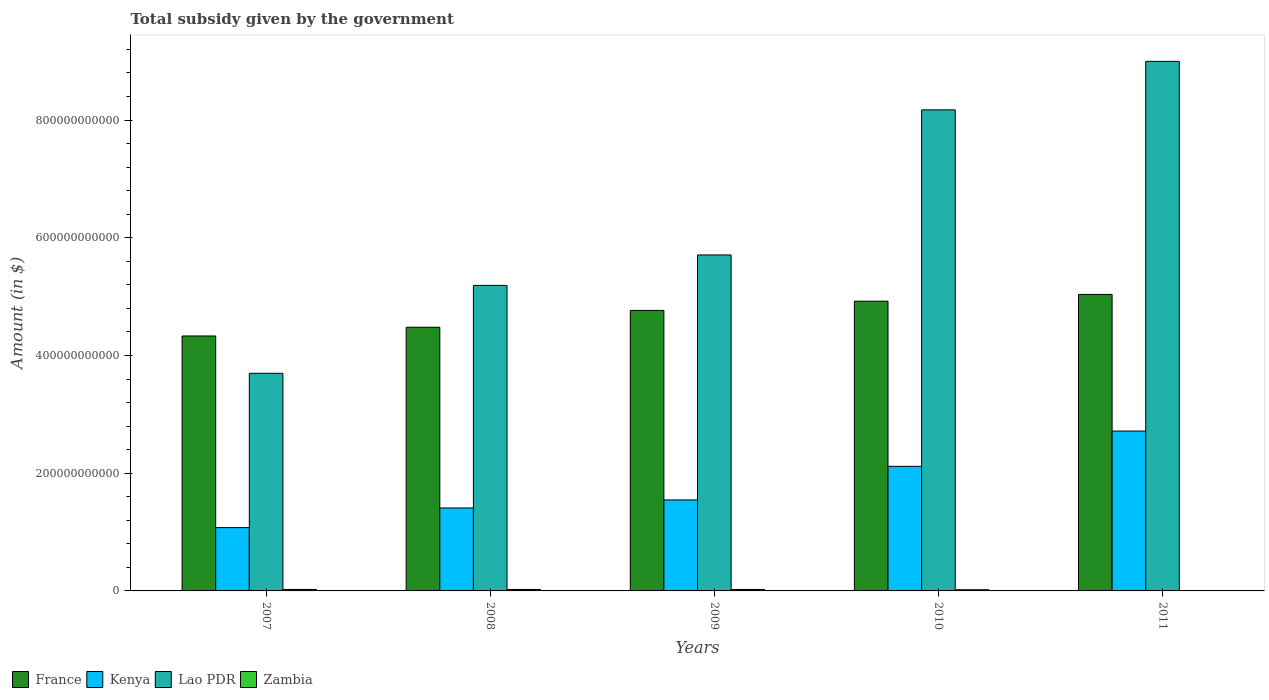How many groups of bars are there?
Your answer should be compact. 5. Are the number of bars on each tick of the X-axis equal?
Provide a short and direct response. Yes. How many bars are there on the 5th tick from the right?
Your response must be concise. 4. What is the label of the 3rd group of bars from the left?
Make the answer very short. 2009. What is the total revenue collected by the government in Zambia in 2007?
Ensure brevity in your answer.  2.52e+09. Across all years, what is the maximum total revenue collected by the government in Kenya?
Give a very brief answer. 2.72e+11. Across all years, what is the minimum total revenue collected by the government in France?
Offer a very short reply. 4.33e+11. In which year was the total revenue collected by the government in Kenya minimum?
Your response must be concise. 2007. What is the total total revenue collected by the government in Zambia in the graph?
Give a very brief answer. 1.02e+1. What is the difference between the total revenue collected by the government in Kenya in 2007 and that in 2010?
Make the answer very short. -1.04e+11. What is the difference between the total revenue collected by the government in France in 2011 and the total revenue collected by the government in Lao PDR in 2007?
Your answer should be very brief. 1.34e+11. What is the average total revenue collected by the government in Lao PDR per year?
Your answer should be very brief. 6.35e+11. In the year 2009, what is the difference between the total revenue collected by the government in France and total revenue collected by the government in Lao PDR?
Make the answer very short. -9.43e+1. What is the ratio of the total revenue collected by the government in Zambia in 2008 to that in 2010?
Keep it short and to the point. 1.22. What is the difference between the highest and the second highest total revenue collected by the government in France?
Offer a very short reply. 1.14e+1. What is the difference between the highest and the lowest total revenue collected by the government in France?
Offer a very short reply. 7.06e+1. What does the 2nd bar from the left in 2009 represents?
Your response must be concise. Kenya. What does the 1st bar from the right in 2010 represents?
Offer a very short reply. Zambia. Is it the case that in every year, the sum of the total revenue collected by the government in France and total revenue collected by the government in Zambia is greater than the total revenue collected by the government in Kenya?
Keep it short and to the point. Yes. How many years are there in the graph?
Your answer should be very brief. 5. What is the difference between two consecutive major ticks on the Y-axis?
Offer a terse response. 2.00e+11. Are the values on the major ticks of Y-axis written in scientific E-notation?
Your answer should be very brief. No. Does the graph contain any zero values?
Provide a short and direct response. No. Where does the legend appear in the graph?
Your response must be concise. Bottom left. How are the legend labels stacked?
Ensure brevity in your answer.  Horizontal. What is the title of the graph?
Ensure brevity in your answer.  Total subsidy given by the government. Does "Sub-Saharan Africa (developing only)" appear as one of the legend labels in the graph?
Your answer should be very brief. No. What is the label or title of the Y-axis?
Your response must be concise. Amount (in $). What is the Amount (in $) in France in 2007?
Keep it short and to the point. 4.33e+11. What is the Amount (in $) in Kenya in 2007?
Keep it short and to the point. 1.08e+11. What is the Amount (in $) of Lao PDR in 2007?
Provide a short and direct response. 3.70e+11. What is the Amount (in $) of Zambia in 2007?
Give a very brief answer. 2.52e+09. What is the Amount (in $) of France in 2008?
Offer a terse response. 4.48e+11. What is the Amount (in $) in Kenya in 2008?
Keep it short and to the point. 1.41e+11. What is the Amount (in $) in Lao PDR in 2008?
Keep it short and to the point. 5.19e+11. What is the Amount (in $) of Zambia in 2008?
Ensure brevity in your answer.  2.48e+09. What is the Amount (in $) in France in 2009?
Offer a very short reply. 4.77e+11. What is the Amount (in $) in Kenya in 2009?
Offer a terse response. 1.55e+11. What is the Amount (in $) in Lao PDR in 2009?
Your answer should be compact. 5.71e+11. What is the Amount (in $) in Zambia in 2009?
Offer a very short reply. 2.49e+09. What is the Amount (in $) in France in 2010?
Make the answer very short. 4.92e+11. What is the Amount (in $) of Kenya in 2010?
Your answer should be compact. 2.12e+11. What is the Amount (in $) in Lao PDR in 2010?
Provide a short and direct response. 8.17e+11. What is the Amount (in $) of Zambia in 2010?
Your answer should be very brief. 2.04e+09. What is the Amount (in $) in France in 2011?
Your response must be concise. 5.04e+11. What is the Amount (in $) in Kenya in 2011?
Provide a succinct answer. 2.72e+11. What is the Amount (in $) of Lao PDR in 2011?
Your answer should be very brief. 9.00e+11. What is the Amount (in $) of Zambia in 2011?
Your answer should be very brief. 6.94e+08. Across all years, what is the maximum Amount (in $) of France?
Provide a short and direct response. 5.04e+11. Across all years, what is the maximum Amount (in $) in Kenya?
Give a very brief answer. 2.72e+11. Across all years, what is the maximum Amount (in $) of Lao PDR?
Your answer should be compact. 9.00e+11. Across all years, what is the maximum Amount (in $) of Zambia?
Offer a very short reply. 2.52e+09. Across all years, what is the minimum Amount (in $) in France?
Give a very brief answer. 4.33e+11. Across all years, what is the minimum Amount (in $) of Kenya?
Make the answer very short. 1.08e+11. Across all years, what is the minimum Amount (in $) in Lao PDR?
Offer a very short reply. 3.70e+11. Across all years, what is the minimum Amount (in $) in Zambia?
Offer a very short reply. 6.94e+08. What is the total Amount (in $) in France in the graph?
Offer a very short reply. 2.35e+12. What is the total Amount (in $) of Kenya in the graph?
Give a very brief answer. 8.86e+11. What is the total Amount (in $) of Lao PDR in the graph?
Your answer should be compact. 3.18e+12. What is the total Amount (in $) of Zambia in the graph?
Ensure brevity in your answer.  1.02e+1. What is the difference between the Amount (in $) in France in 2007 and that in 2008?
Make the answer very short. -1.49e+1. What is the difference between the Amount (in $) in Kenya in 2007 and that in 2008?
Keep it short and to the point. -3.34e+1. What is the difference between the Amount (in $) of Lao PDR in 2007 and that in 2008?
Your response must be concise. -1.49e+11. What is the difference between the Amount (in $) in Zambia in 2007 and that in 2008?
Your answer should be very brief. 4.39e+07. What is the difference between the Amount (in $) in France in 2007 and that in 2009?
Provide a short and direct response. -4.34e+1. What is the difference between the Amount (in $) in Kenya in 2007 and that in 2009?
Ensure brevity in your answer.  -4.70e+1. What is the difference between the Amount (in $) of Lao PDR in 2007 and that in 2009?
Offer a terse response. -2.01e+11. What is the difference between the Amount (in $) of Zambia in 2007 and that in 2009?
Provide a short and direct response. 2.92e+07. What is the difference between the Amount (in $) of France in 2007 and that in 2010?
Your answer should be very brief. -5.92e+1. What is the difference between the Amount (in $) of Kenya in 2007 and that in 2010?
Provide a short and direct response. -1.04e+11. What is the difference between the Amount (in $) of Lao PDR in 2007 and that in 2010?
Offer a terse response. -4.48e+11. What is the difference between the Amount (in $) of Zambia in 2007 and that in 2010?
Your answer should be very brief. 4.87e+08. What is the difference between the Amount (in $) in France in 2007 and that in 2011?
Your answer should be very brief. -7.06e+1. What is the difference between the Amount (in $) in Kenya in 2007 and that in 2011?
Your answer should be compact. -1.64e+11. What is the difference between the Amount (in $) of Lao PDR in 2007 and that in 2011?
Offer a terse response. -5.30e+11. What is the difference between the Amount (in $) in Zambia in 2007 and that in 2011?
Make the answer very short. 1.83e+09. What is the difference between the Amount (in $) of France in 2008 and that in 2009?
Offer a very short reply. -2.86e+1. What is the difference between the Amount (in $) of Kenya in 2008 and that in 2009?
Give a very brief answer. -1.37e+1. What is the difference between the Amount (in $) in Lao PDR in 2008 and that in 2009?
Make the answer very short. -5.17e+1. What is the difference between the Amount (in $) in Zambia in 2008 and that in 2009?
Offer a very short reply. -1.47e+07. What is the difference between the Amount (in $) in France in 2008 and that in 2010?
Make the answer very short. -4.43e+1. What is the difference between the Amount (in $) of Kenya in 2008 and that in 2010?
Provide a succinct answer. -7.07e+1. What is the difference between the Amount (in $) in Lao PDR in 2008 and that in 2010?
Provide a short and direct response. -2.98e+11. What is the difference between the Amount (in $) of Zambia in 2008 and that in 2010?
Your response must be concise. 4.43e+08. What is the difference between the Amount (in $) in France in 2008 and that in 2011?
Your answer should be compact. -5.57e+1. What is the difference between the Amount (in $) in Kenya in 2008 and that in 2011?
Your answer should be compact. -1.31e+11. What is the difference between the Amount (in $) of Lao PDR in 2008 and that in 2011?
Offer a terse response. -3.81e+11. What is the difference between the Amount (in $) in Zambia in 2008 and that in 2011?
Offer a very short reply. 1.78e+09. What is the difference between the Amount (in $) of France in 2009 and that in 2010?
Your response must be concise. -1.57e+1. What is the difference between the Amount (in $) of Kenya in 2009 and that in 2010?
Give a very brief answer. -5.71e+1. What is the difference between the Amount (in $) of Lao PDR in 2009 and that in 2010?
Keep it short and to the point. -2.47e+11. What is the difference between the Amount (in $) in Zambia in 2009 and that in 2010?
Offer a terse response. 4.58e+08. What is the difference between the Amount (in $) of France in 2009 and that in 2011?
Your answer should be compact. -2.72e+1. What is the difference between the Amount (in $) in Kenya in 2009 and that in 2011?
Ensure brevity in your answer.  -1.17e+11. What is the difference between the Amount (in $) in Lao PDR in 2009 and that in 2011?
Make the answer very short. -3.29e+11. What is the difference between the Amount (in $) in Zambia in 2009 and that in 2011?
Offer a terse response. 1.80e+09. What is the difference between the Amount (in $) of France in 2010 and that in 2011?
Your response must be concise. -1.14e+1. What is the difference between the Amount (in $) in Kenya in 2010 and that in 2011?
Make the answer very short. -6.00e+1. What is the difference between the Amount (in $) of Lao PDR in 2010 and that in 2011?
Give a very brief answer. -8.24e+1. What is the difference between the Amount (in $) in Zambia in 2010 and that in 2011?
Provide a short and direct response. 1.34e+09. What is the difference between the Amount (in $) in France in 2007 and the Amount (in $) in Kenya in 2008?
Your answer should be compact. 2.92e+11. What is the difference between the Amount (in $) in France in 2007 and the Amount (in $) in Lao PDR in 2008?
Provide a short and direct response. -8.59e+1. What is the difference between the Amount (in $) of France in 2007 and the Amount (in $) of Zambia in 2008?
Provide a succinct answer. 4.31e+11. What is the difference between the Amount (in $) in Kenya in 2007 and the Amount (in $) in Lao PDR in 2008?
Provide a short and direct response. -4.12e+11. What is the difference between the Amount (in $) of Kenya in 2007 and the Amount (in $) of Zambia in 2008?
Provide a short and direct response. 1.05e+11. What is the difference between the Amount (in $) of Lao PDR in 2007 and the Amount (in $) of Zambia in 2008?
Your answer should be compact. 3.67e+11. What is the difference between the Amount (in $) in France in 2007 and the Amount (in $) in Kenya in 2009?
Keep it short and to the point. 2.79e+11. What is the difference between the Amount (in $) of France in 2007 and the Amount (in $) of Lao PDR in 2009?
Offer a very short reply. -1.38e+11. What is the difference between the Amount (in $) in France in 2007 and the Amount (in $) in Zambia in 2009?
Your answer should be compact. 4.31e+11. What is the difference between the Amount (in $) of Kenya in 2007 and the Amount (in $) of Lao PDR in 2009?
Give a very brief answer. -4.63e+11. What is the difference between the Amount (in $) of Kenya in 2007 and the Amount (in $) of Zambia in 2009?
Provide a short and direct response. 1.05e+11. What is the difference between the Amount (in $) of Lao PDR in 2007 and the Amount (in $) of Zambia in 2009?
Ensure brevity in your answer.  3.67e+11. What is the difference between the Amount (in $) in France in 2007 and the Amount (in $) in Kenya in 2010?
Give a very brief answer. 2.21e+11. What is the difference between the Amount (in $) in France in 2007 and the Amount (in $) in Lao PDR in 2010?
Make the answer very short. -3.84e+11. What is the difference between the Amount (in $) in France in 2007 and the Amount (in $) in Zambia in 2010?
Provide a succinct answer. 4.31e+11. What is the difference between the Amount (in $) of Kenya in 2007 and the Amount (in $) of Lao PDR in 2010?
Offer a very short reply. -7.10e+11. What is the difference between the Amount (in $) of Kenya in 2007 and the Amount (in $) of Zambia in 2010?
Offer a terse response. 1.06e+11. What is the difference between the Amount (in $) in Lao PDR in 2007 and the Amount (in $) in Zambia in 2010?
Offer a terse response. 3.68e+11. What is the difference between the Amount (in $) in France in 2007 and the Amount (in $) in Kenya in 2011?
Your response must be concise. 1.62e+11. What is the difference between the Amount (in $) in France in 2007 and the Amount (in $) in Lao PDR in 2011?
Provide a succinct answer. -4.67e+11. What is the difference between the Amount (in $) of France in 2007 and the Amount (in $) of Zambia in 2011?
Offer a very short reply. 4.32e+11. What is the difference between the Amount (in $) of Kenya in 2007 and the Amount (in $) of Lao PDR in 2011?
Your response must be concise. -7.92e+11. What is the difference between the Amount (in $) of Kenya in 2007 and the Amount (in $) of Zambia in 2011?
Provide a succinct answer. 1.07e+11. What is the difference between the Amount (in $) in Lao PDR in 2007 and the Amount (in $) in Zambia in 2011?
Make the answer very short. 3.69e+11. What is the difference between the Amount (in $) in France in 2008 and the Amount (in $) in Kenya in 2009?
Provide a short and direct response. 2.93e+11. What is the difference between the Amount (in $) in France in 2008 and the Amount (in $) in Lao PDR in 2009?
Give a very brief answer. -1.23e+11. What is the difference between the Amount (in $) in France in 2008 and the Amount (in $) in Zambia in 2009?
Give a very brief answer. 4.46e+11. What is the difference between the Amount (in $) of Kenya in 2008 and the Amount (in $) of Lao PDR in 2009?
Provide a short and direct response. -4.30e+11. What is the difference between the Amount (in $) in Kenya in 2008 and the Amount (in $) in Zambia in 2009?
Offer a very short reply. 1.38e+11. What is the difference between the Amount (in $) of Lao PDR in 2008 and the Amount (in $) of Zambia in 2009?
Your response must be concise. 5.17e+11. What is the difference between the Amount (in $) in France in 2008 and the Amount (in $) in Kenya in 2010?
Offer a terse response. 2.36e+11. What is the difference between the Amount (in $) of France in 2008 and the Amount (in $) of Lao PDR in 2010?
Offer a terse response. -3.69e+11. What is the difference between the Amount (in $) of France in 2008 and the Amount (in $) of Zambia in 2010?
Your response must be concise. 4.46e+11. What is the difference between the Amount (in $) in Kenya in 2008 and the Amount (in $) in Lao PDR in 2010?
Ensure brevity in your answer.  -6.76e+11. What is the difference between the Amount (in $) of Kenya in 2008 and the Amount (in $) of Zambia in 2010?
Your response must be concise. 1.39e+11. What is the difference between the Amount (in $) of Lao PDR in 2008 and the Amount (in $) of Zambia in 2010?
Your answer should be compact. 5.17e+11. What is the difference between the Amount (in $) of France in 2008 and the Amount (in $) of Kenya in 2011?
Give a very brief answer. 1.76e+11. What is the difference between the Amount (in $) in France in 2008 and the Amount (in $) in Lao PDR in 2011?
Make the answer very short. -4.52e+11. What is the difference between the Amount (in $) in France in 2008 and the Amount (in $) in Zambia in 2011?
Ensure brevity in your answer.  4.47e+11. What is the difference between the Amount (in $) in Kenya in 2008 and the Amount (in $) in Lao PDR in 2011?
Your answer should be very brief. -7.59e+11. What is the difference between the Amount (in $) of Kenya in 2008 and the Amount (in $) of Zambia in 2011?
Keep it short and to the point. 1.40e+11. What is the difference between the Amount (in $) of Lao PDR in 2008 and the Amount (in $) of Zambia in 2011?
Make the answer very short. 5.18e+11. What is the difference between the Amount (in $) of France in 2009 and the Amount (in $) of Kenya in 2010?
Provide a succinct answer. 2.65e+11. What is the difference between the Amount (in $) in France in 2009 and the Amount (in $) in Lao PDR in 2010?
Your answer should be very brief. -3.41e+11. What is the difference between the Amount (in $) of France in 2009 and the Amount (in $) of Zambia in 2010?
Your answer should be compact. 4.75e+11. What is the difference between the Amount (in $) of Kenya in 2009 and the Amount (in $) of Lao PDR in 2010?
Offer a very short reply. -6.63e+11. What is the difference between the Amount (in $) of Kenya in 2009 and the Amount (in $) of Zambia in 2010?
Your answer should be compact. 1.53e+11. What is the difference between the Amount (in $) in Lao PDR in 2009 and the Amount (in $) in Zambia in 2010?
Your answer should be compact. 5.69e+11. What is the difference between the Amount (in $) of France in 2009 and the Amount (in $) of Kenya in 2011?
Your answer should be compact. 2.05e+11. What is the difference between the Amount (in $) in France in 2009 and the Amount (in $) in Lao PDR in 2011?
Provide a short and direct response. -4.23e+11. What is the difference between the Amount (in $) of France in 2009 and the Amount (in $) of Zambia in 2011?
Offer a terse response. 4.76e+11. What is the difference between the Amount (in $) of Kenya in 2009 and the Amount (in $) of Lao PDR in 2011?
Provide a succinct answer. -7.45e+11. What is the difference between the Amount (in $) in Kenya in 2009 and the Amount (in $) in Zambia in 2011?
Offer a terse response. 1.54e+11. What is the difference between the Amount (in $) of Lao PDR in 2009 and the Amount (in $) of Zambia in 2011?
Provide a succinct answer. 5.70e+11. What is the difference between the Amount (in $) of France in 2010 and the Amount (in $) of Kenya in 2011?
Your answer should be very brief. 2.21e+11. What is the difference between the Amount (in $) of France in 2010 and the Amount (in $) of Lao PDR in 2011?
Provide a short and direct response. -4.07e+11. What is the difference between the Amount (in $) of France in 2010 and the Amount (in $) of Zambia in 2011?
Offer a terse response. 4.92e+11. What is the difference between the Amount (in $) in Kenya in 2010 and the Amount (in $) in Lao PDR in 2011?
Your answer should be compact. -6.88e+11. What is the difference between the Amount (in $) of Kenya in 2010 and the Amount (in $) of Zambia in 2011?
Give a very brief answer. 2.11e+11. What is the difference between the Amount (in $) of Lao PDR in 2010 and the Amount (in $) of Zambia in 2011?
Provide a short and direct response. 8.17e+11. What is the average Amount (in $) in France per year?
Offer a very short reply. 4.71e+11. What is the average Amount (in $) in Kenya per year?
Your answer should be very brief. 1.77e+11. What is the average Amount (in $) in Lao PDR per year?
Give a very brief answer. 6.35e+11. What is the average Amount (in $) in Zambia per year?
Your response must be concise. 2.04e+09. In the year 2007, what is the difference between the Amount (in $) of France and Amount (in $) of Kenya?
Make the answer very short. 3.26e+11. In the year 2007, what is the difference between the Amount (in $) of France and Amount (in $) of Lao PDR?
Your answer should be very brief. 6.34e+1. In the year 2007, what is the difference between the Amount (in $) in France and Amount (in $) in Zambia?
Your response must be concise. 4.31e+11. In the year 2007, what is the difference between the Amount (in $) in Kenya and Amount (in $) in Lao PDR?
Offer a very short reply. -2.62e+11. In the year 2007, what is the difference between the Amount (in $) of Kenya and Amount (in $) of Zambia?
Your answer should be compact. 1.05e+11. In the year 2007, what is the difference between the Amount (in $) in Lao PDR and Amount (in $) in Zambia?
Make the answer very short. 3.67e+11. In the year 2008, what is the difference between the Amount (in $) in France and Amount (in $) in Kenya?
Offer a terse response. 3.07e+11. In the year 2008, what is the difference between the Amount (in $) in France and Amount (in $) in Lao PDR?
Provide a succinct answer. -7.11e+1. In the year 2008, what is the difference between the Amount (in $) of France and Amount (in $) of Zambia?
Make the answer very short. 4.46e+11. In the year 2008, what is the difference between the Amount (in $) of Kenya and Amount (in $) of Lao PDR?
Provide a succinct answer. -3.78e+11. In the year 2008, what is the difference between the Amount (in $) of Kenya and Amount (in $) of Zambia?
Offer a terse response. 1.38e+11. In the year 2008, what is the difference between the Amount (in $) of Lao PDR and Amount (in $) of Zambia?
Offer a very short reply. 5.17e+11. In the year 2009, what is the difference between the Amount (in $) of France and Amount (in $) of Kenya?
Your response must be concise. 3.22e+11. In the year 2009, what is the difference between the Amount (in $) of France and Amount (in $) of Lao PDR?
Offer a very short reply. -9.43e+1. In the year 2009, what is the difference between the Amount (in $) of France and Amount (in $) of Zambia?
Offer a terse response. 4.74e+11. In the year 2009, what is the difference between the Amount (in $) in Kenya and Amount (in $) in Lao PDR?
Offer a very short reply. -4.16e+11. In the year 2009, what is the difference between the Amount (in $) of Kenya and Amount (in $) of Zambia?
Your response must be concise. 1.52e+11. In the year 2009, what is the difference between the Amount (in $) in Lao PDR and Amount (in $) in Zambia?
Make the answer very short. 5.68e+11. In the year 2010, what is the difference between the Amount (in $) in France and Amount (in $) in Kenya?
Give a very brief answer. 2.81e+11. In the year 2010, what is the difference between the Amount (in $) of France and Amount (in $) of Lao PDR?
Ensure brevity in your answer.  -3.25e+11. In the year 2010, what is the difference between the Amount (in $) in France and Amount (in $) in Zambia?
Offer a very short reply. 4.90e+11. In the year 2010, what is the difference between the Amount (in $) in Kenya and Amount (in $) in Lao PDR?
Provide a succinct answer. -6.06e+11. In the year 2010, what is the difference between the Amount (in $) of Kenya and Amount (in $) of Zambia?
Your response must be concise. 2.10e+11. In the year 2010, what is the difference between the Amount (in $) in Lao PDR and Amount (in $) in Zambia?
Provide a succinct answer. 8.15e+11. In the year 2011, what is the difference between the Amount (in $) in France and Amount (in $) in Kenya?
Ensure brevity in your answer.  2.32e+11. In the year 2011, what is the difference between the Amount (in $) of France and Amount (in $) of Lao PDR?
Provide a short and direct response. -3.96e+11. In the year 2011, what is the difference between the Amount (in $) in France and Amount (in $) in Zambia?
Provide a succinct answer. 5.03e+11. In the year 2011, what is the difference between the Amount (in $) in Kenya and Amount (in $) in Lao PDR?
Keep it short and to the point. -6.28e+11. In the year 2011, what is the difference between the Amount (in $) of Kenya and Amount (in $) of Zambia?
Provide a succinct answer. 2.71e+11. In the year 2011, what is the difference between the Amount (in $) of Lao PDR and Amount (in $) of Zambia?
Your answer should be very brief. 8.99e+11. What is the ratio of the Amount (in $) in France in 2007 to that in 2008?
Keep it short and to the point. 0.97. What is the ratio of the Amount (in $) in Kenya in 2007 to that in 2008?
Offer a terse response. 0.76. What is the ratio of the Amount (in $) in Lao PDR in 2007 to that in 2008?
Offer a very short reply. 0.71. What is the ratio of the Amount (in $) of Zambia in 2007 to that in 2008?
Keep it short and to the point. 1.02. What is the ratio of the Amount (in $) of France in 2007 to that in 2009?
Your response must be concise. 0.91. What is the ratio of the Amount (in $) in Kenya in 2007 to that in 2009?
Your answer should be very brief. 0.7. What is the ratio of the Amount (in $) in Lao PDR in 2007 to that in 2009?
Provide a succinct answer. 0.65. What is the ratio of the Amount (in $) in Zambia in 2007 to that in 2009?
Your response must be concise. 1.01. What is the ratio of the Amount (in $) of France in 2007 to that in 2010?
Your answer should be very brief. 0.88. What is the ratio of the Amount (in $) in Kenya in 2007 to that in 2010?
Keep it short and to the point. 0.51. What is the ratio of the Amount (in $) in Lao PDR in 2007 to that in 2010?
Make the answer very short. 0.45. What is the ratio of the Amount (in $) of Zambia in 2007 to that in 2010?
Your answer should be very brief. 1.24. What is the ratio of the Amount (in $) of France in 2007 to that in 2011?
Your response must be concise. 0.86. What is the ratio of the Amount (in $) of Kenya in 2007 to that in 2011?
Offer a terse response. 0.4. What is the ratio of the Amount (in $) in Lao PDR in 2007 to that in 2011?
Offer a terse response. 0.41. What is the ratio of the Amount (in $) of Zambia in 2007 to that in 2011?
Offer a terse response. 3.64. What is the ratio of the Amount (in $) in France in 2008 to that in 2009?
Make the answer very short. 0.94. What is the ratio of the Amount (in $) of Kenya in 2008 to that in 2009?
Provide a succinct answer. 0.91. What is the ratio of the Amount (in $) of Lao PDR in 2008 to that in 2009?
Provide a short and direct response. 0.91. What is the ratio of the Amount (in $) in Zambia in 2008 to that in 2009?
Make the answer very short. 0.99. What is the ratio of the Amount (in $) of France in 2008 to that in 2010?
Provide a short and direct response. 0.91. What is the ratio of the Amount (in $) in Kenya in 2008 to that in 2010?
Give a very brief answer. 0.67. What is the ratio of the Amount (in $) in Lao PDR in 2008 to that in 2010?
Make the answer very short. 0.64. What is the ratio of the Amount (in $) of Zambia in 2008 to that in 2010?
Your answer should be compact. 1.22. What is the ratio of the Amount (in $) of France in 2008 to that in 2011?
Your answer should be very brief. 0.89. What is the ratio of the Amount (in $) in Kenya in 2008 to that in 2011?
Your answer should be very brief. 0.52. What is the ratio of the Amount (in $) of Lao PDR in 2008 to that in 2011?
Make the answer very short. 0.58. What is the ratio of the Amount (in $) of Zambia in 2008 to that in 2011?
Offer a terse response. 3.57. What is the ratio of the Amount (in $) of Kenya in 2009 to that in 2010?
Make the answer very short. 0.73. What is the ratio of the Amount (in $) in Lao PDR in 2009 to that in 2010?
Your answer should be compact. 0.7. What is the ratio of the Amount (in $) in Zambia in 2009 to that in 2010?
Your response must be concise. 1.23. What is the ratio of the Amount (in $) in France in 2009 to that in 2011?
Your response must be concise. 0.95. What is the ratio of the Amount (in $) of Kenya in 2009 to that in 2011?
Provide a short and direct response. 0.57. What is the ratio of the Amount (in $) of Lao PDR in 2009 to that in 2011?
Provide a short and direct response. 0.63. What is the ratio of the Amount (in $) in Zambia in 2009 to that in 2011?
Offer a terse response. 3.59. What is the ratio of the Amount (in $) in France in 2010 to that in 2011?
Offer a terse response. 0.98. What is the ratio of the Amount (in $) of Kenya in 2010 to that in 2011?
Your response must be concise. 0.78. What is the ratio of the Amount (in $) in Lao PDR in 2010 to that in 2011?
Provide a short and direct response. 0.91. What is the ratio of the Amount (in $) of Zambia in 2010 to that in 2011?
Ensure brevity in your answer.  2.93. What is the difference between the highest and the second highest Amount (in $) of France?
Provide a succinct answer. 1.14e+1. What is the difference between the highest and the second highest Amount (in $) in Kenya?
Your response must be concise. 6.00e+1. What is the difference between the highest and the second highest Amount (in $) in Lao PDR?
Keep it short and to the point. 8.24e+1. What is the difference between the highest and the second highest Amount (in $) of Zambia?
Give a very brief answer. 2.92e+07. What is the difference between the highest and the lowest Amount (in $) of France?
Ensure brevity in your answer.  7.06e+1. What is the difference between the highest and the lowest Amount (in $) of Kenya?
Offer a very short reply. 1.64e+11. What is the difference between the highest and the lowest Amount (in $) of Lao PDR?
Your answer should be compact. 5.30e+11. What is the difference between the highest and the lowest Amount (in $) in Zambia?
Provide a short and direct response. 1.83e+09. 